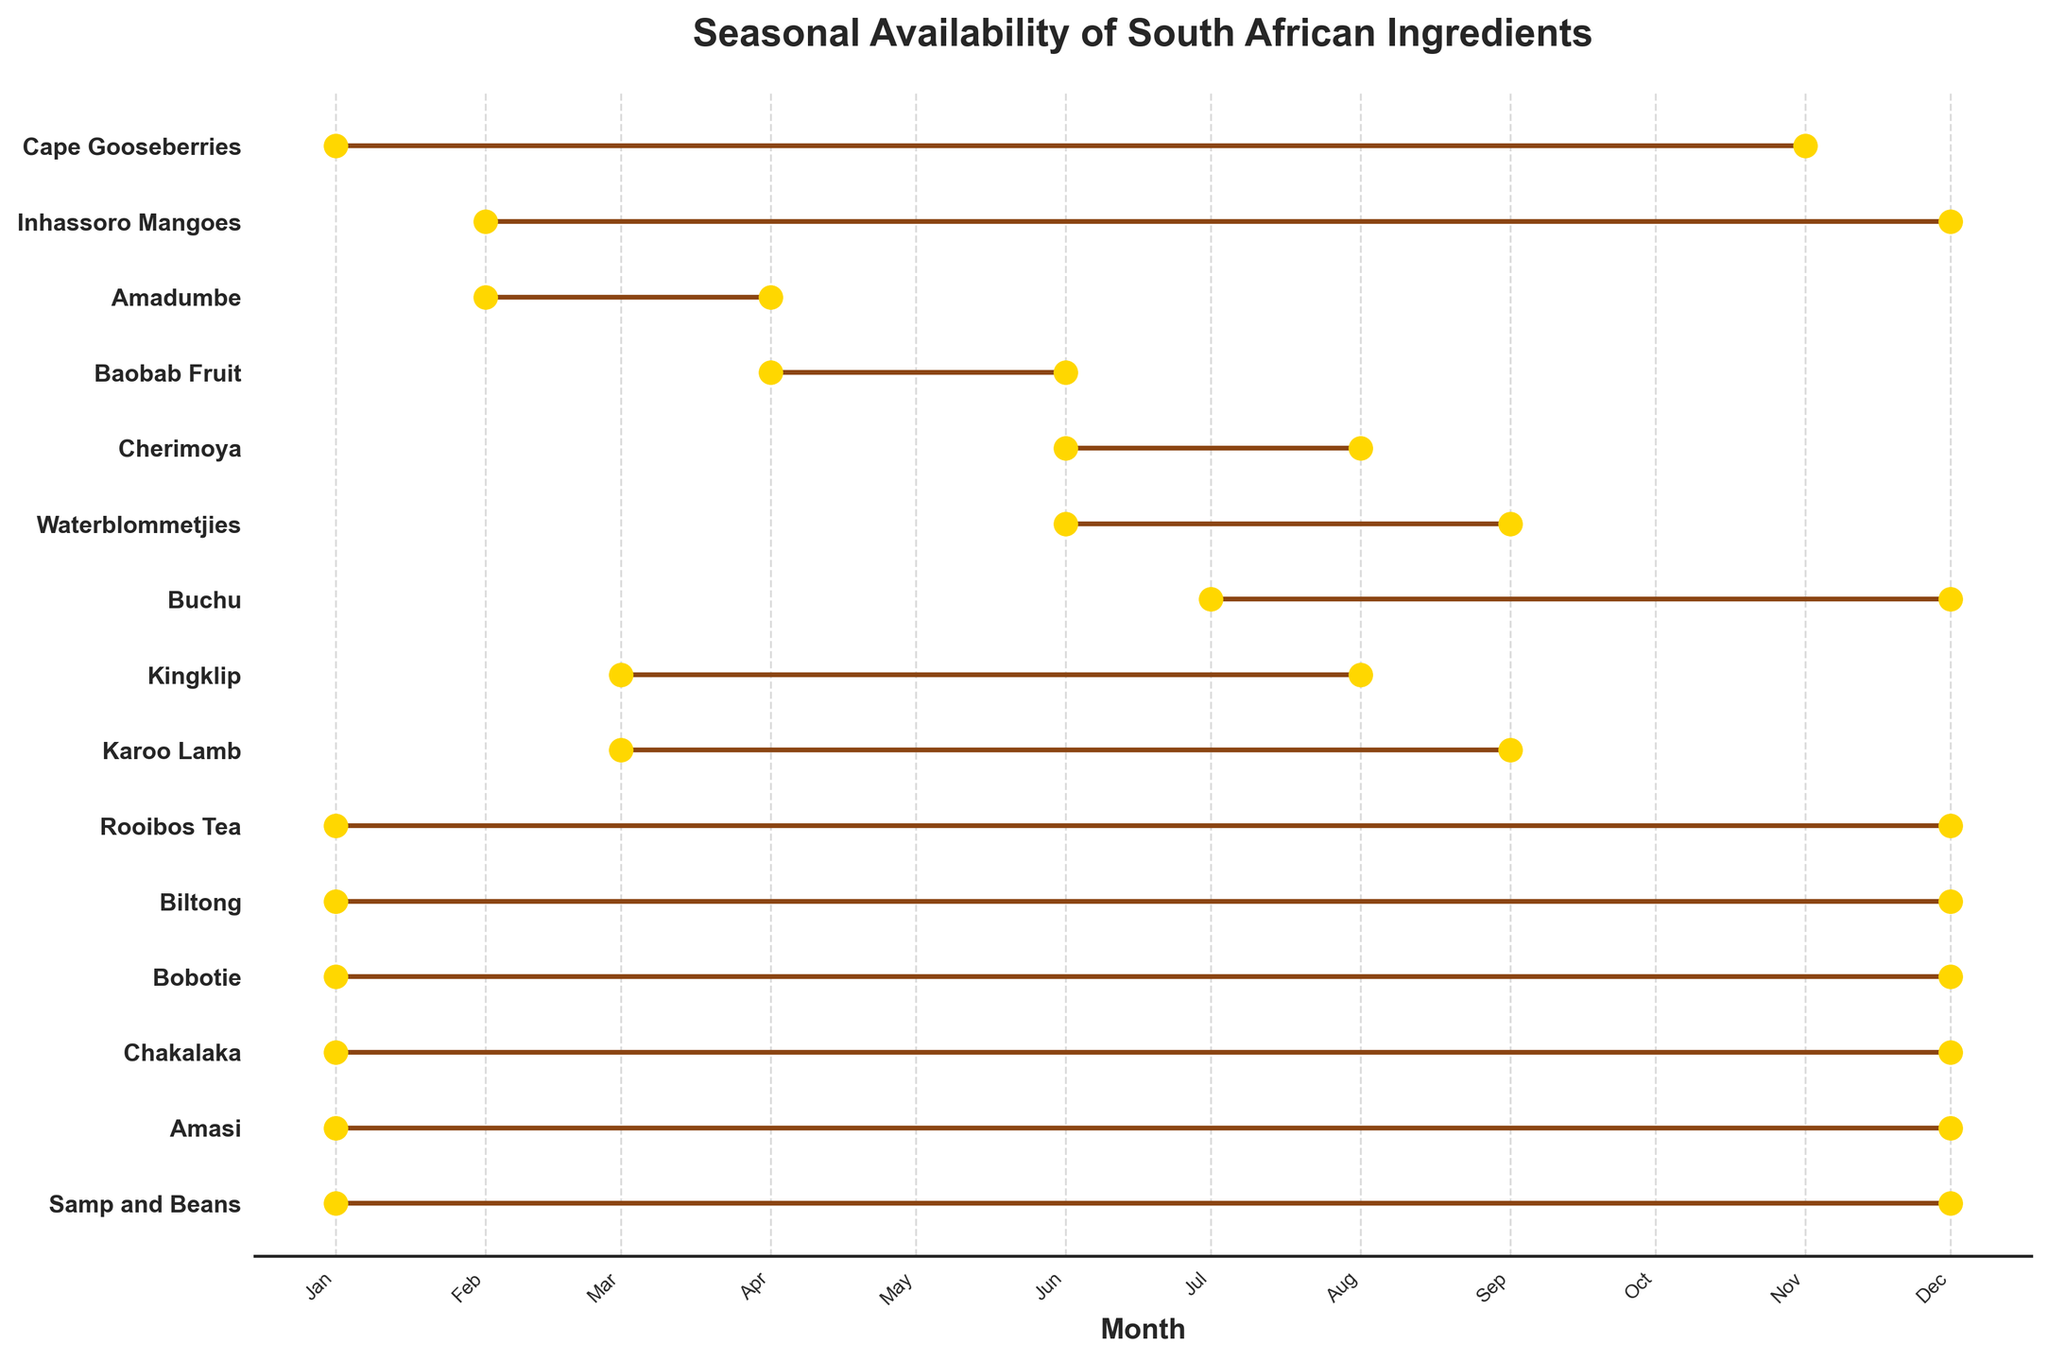What is the title of the plot? The plot's title is usually written at the top in bold and prominent text. In this case, it indicates the main subject of the plot.
Answer: Seasonal Availability of South African Ingredients How many ingredients are available for the entire year? To determine this, identify the lines in the plot that extend from the beginning of the year (January) to the end of the year (December).
Answer: 7 During which months is Karoo Lamb available? Look for the specific line corresponding to Karoo Lamb and observe the starting and ending points on the x-axis, which represent the months.
Answer: March to September Which ingredient has the shortest availability period? The ingredient with the shortest line in the plot represents the shortest availability period.
Answer: Cherimoya How many ingredients are available in June? Count the number of lines that intersect with the month of June on the x-axis.
Answer: 8 Between Karoo Lamb and Cherimoya, which one is available for a longer period? Compare the lengths of the lines corresponding to these two ingredients and see which one spans more months.
Answer: Karoo Lamb Which ingredients overlap in availability during the month of August? Identify the lines that intersect with August on the x-axis and list the corresponding ingredients.
Answer: Cherimoya, Waterblommetjies, Kingklip, Karoo Lamb Which ingredient has the longest availability period? The ingredient with the longest continuous line in the plot represents the longest availability period.
Answer: Samp and Beans (tied with other year-round ingredients) In which month does Buchu's availability start? Look at the starting point of Buchu's line on the x-axis to determine the month.
Answer: July 